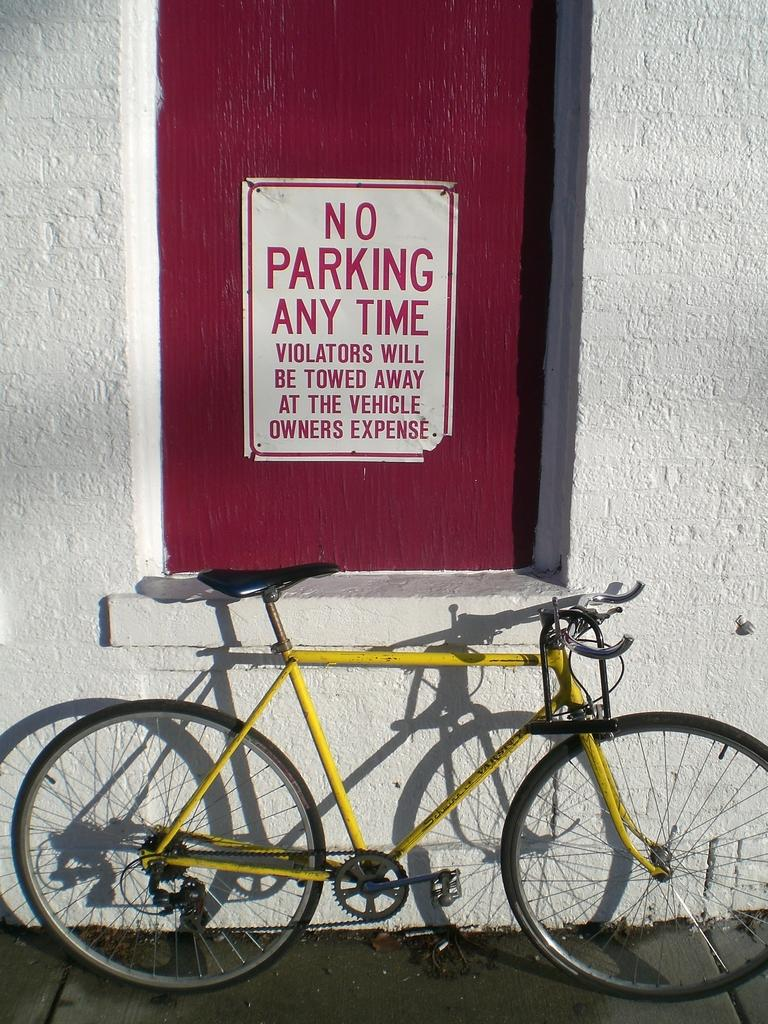What is the main object in the image? There is a bicycle in the image. What else can be seen in the image besides the bicycle? There is a board and a wall in the image. Can you describe the lighting in the image? The image was likely taken during the day, as there is sufficient light to see the objects clearly. How many servants are visible in the image? There are no servants present in the image. What type of acoustics can be heard in the image? There is no sound or audio present in the image, so it is not possible to determine the acoustics. 